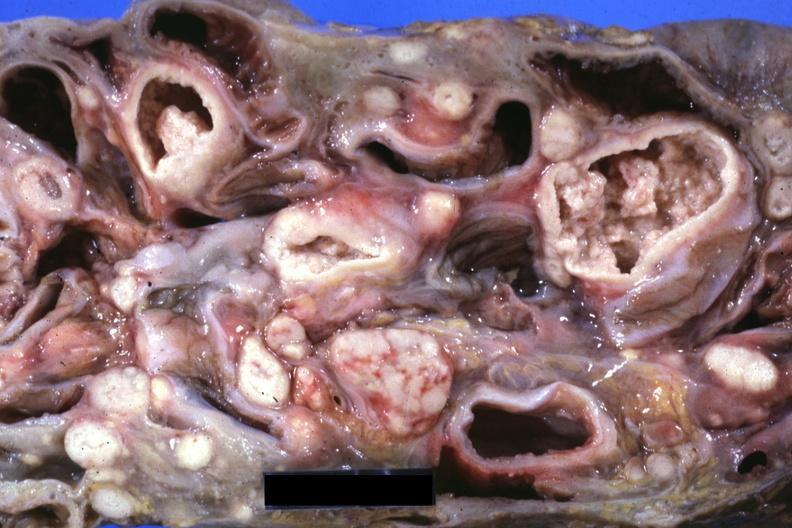what is present?
Answer the question using a single word or phrase. Lymph node 